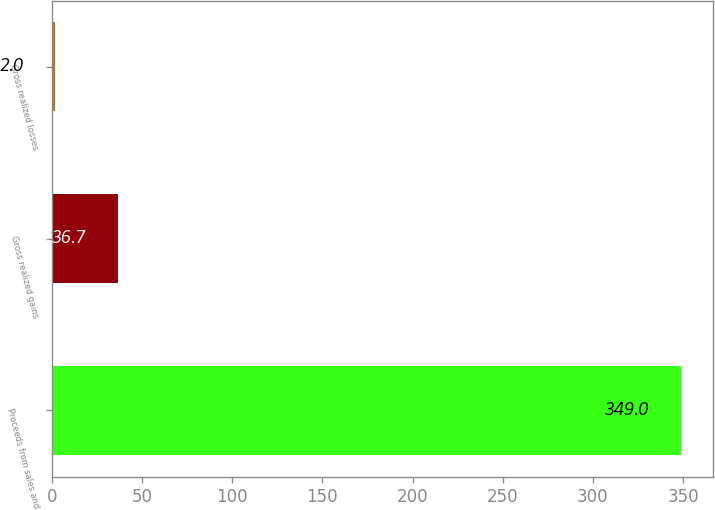<chart> <loc_0><loc_0><loc_500><loc_500><bar_chart><fcel>Proceeds from sales and<fcel>Gross realized gains<fcel>Gross realized losses<nl><fcel>349<fcel>36.7<fcel>2<nl></chart> 